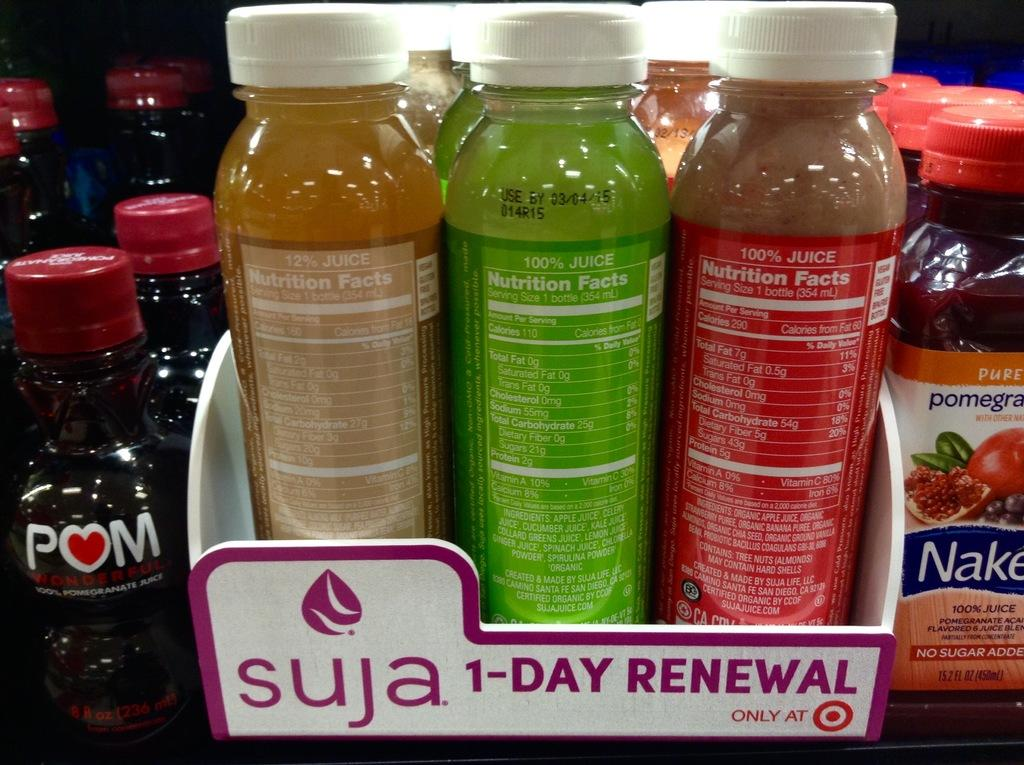What object is present in the image that is made of glass? There is a glass bottle in the image. Where is the glass bottle located in the image? The glass bottle is in a tray. What type of sack is being used to transport the glass bottle in the image? There is no sack present in the image, and the glass bottle is in a tray, not being transported. 